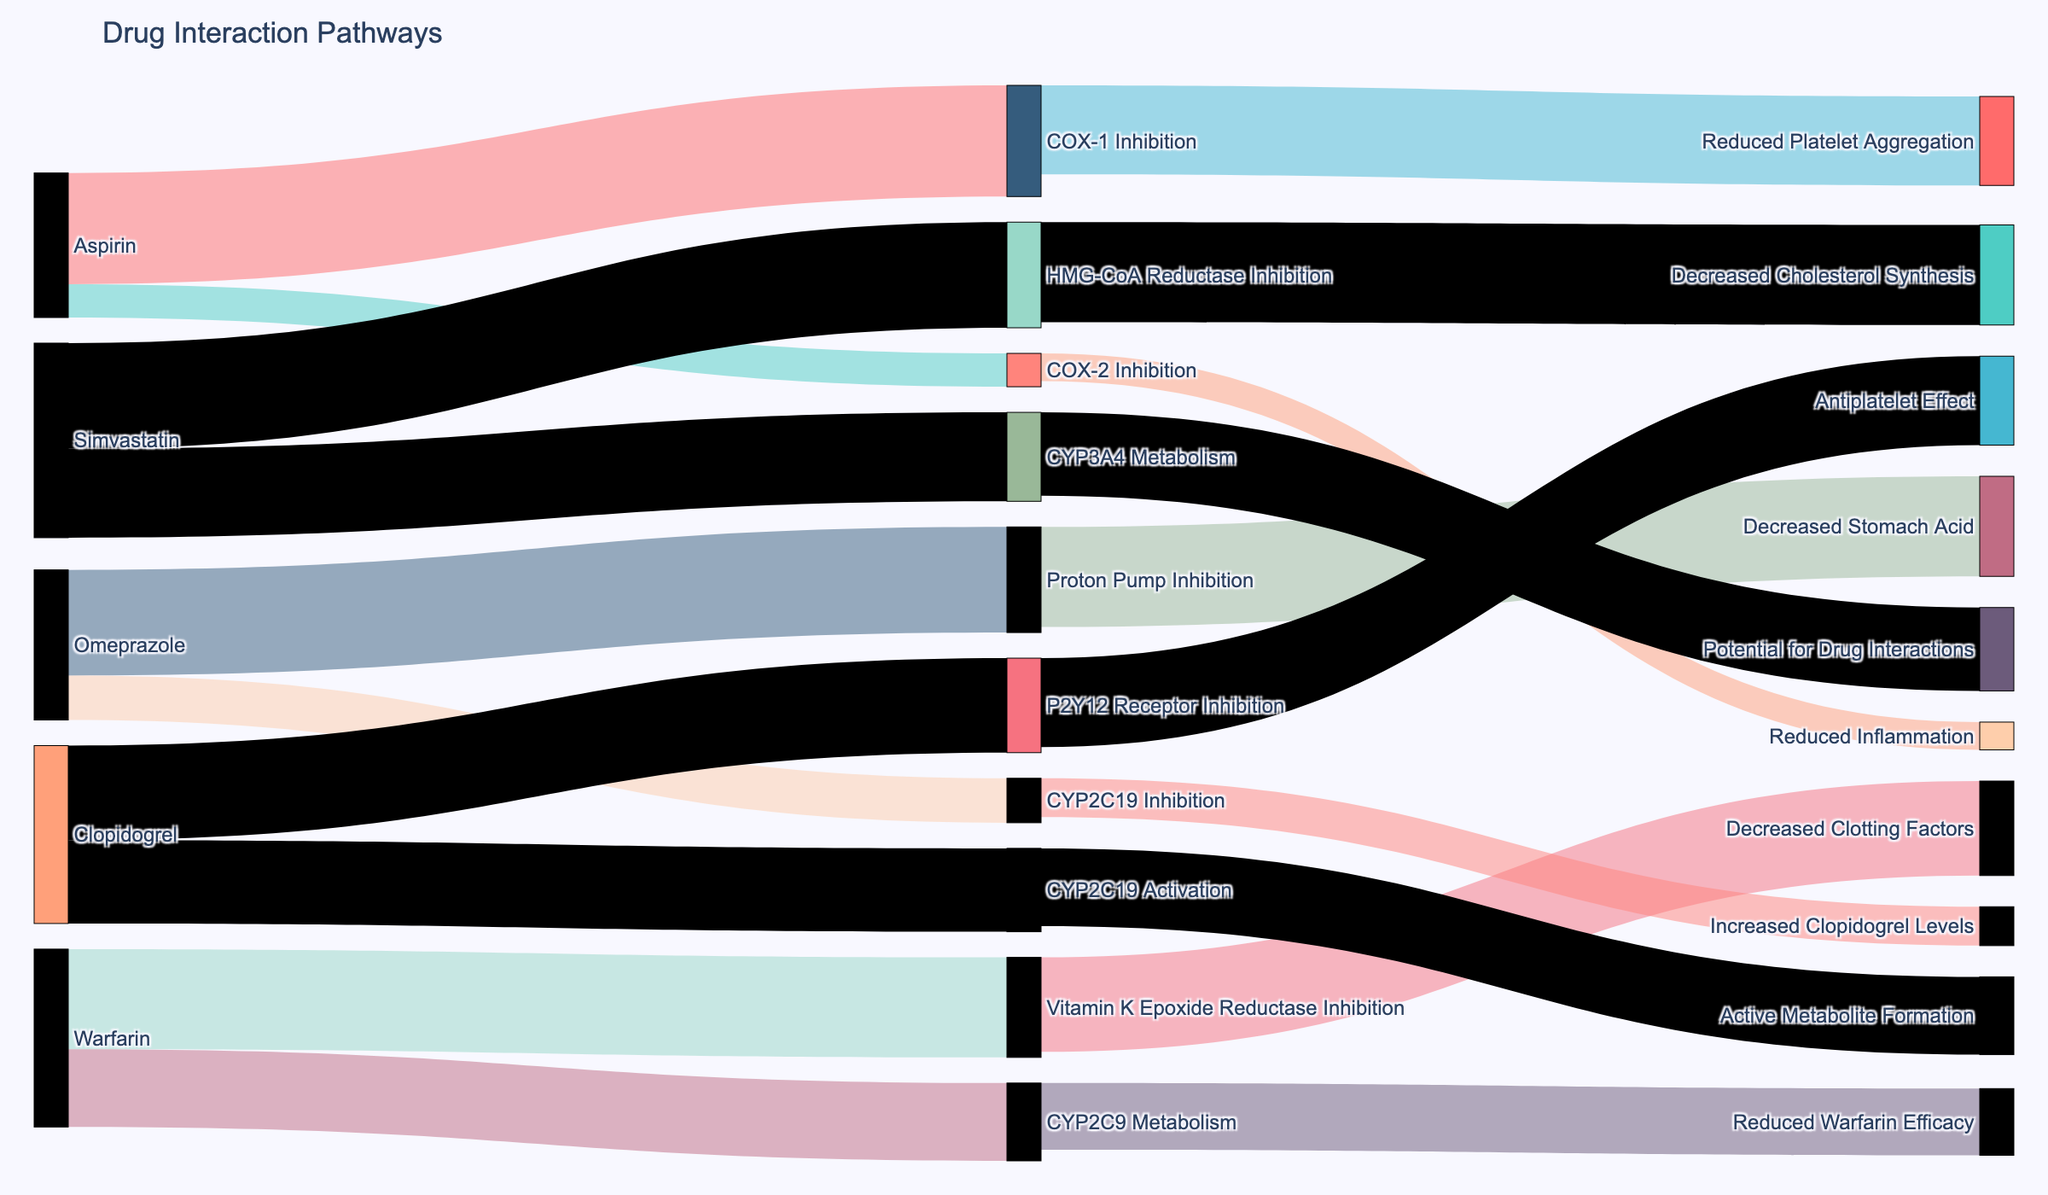What are the pathways influenced by Aspirin? The Sankey diagram shows that Aspirin affects COX-1 Inhibition and COX-2 Inhibition. COX-1 Inhibition further leads to Reduced Platelet Aggregation, and COX-2 Inhibition leads to Reduced Inflammation.
Answer: COX-1 Inhibition and COX-2 Inhibition What is the primary interaction pathway for Warfarin? By examining the Sankey diagram, we can see that Warfarin primarily interacts with Vitamin K Epoxide Reductase Inhibition and CYP2C9 Metabolism.
Answer: Vitamin K Epoxide Reductase Inhibition and CYP2C9 Metabolism Between Omeprazole and Simvastatin, which medication affects more pathways directly? The Sankey diagram shows that Omeprazole affects Proton Pump Inhibition and CYP2C19 Inhibition, resulting in two direct pathways. Simvastatin affects HMG-CoA Reductase Inhibition and CYP3A4 Metabolism, also leading to two direct pathways. Therefore, they affect an equal number of pathways directly.
Answer: Equal (2 pathways each) What are the secondary interactions arising from Clopidogrel? Clopidogrel affects P2Y12 Receptor Inhibition and CYP2C19 Activation. These lead to Antiplatelet Effect and Active Metabolite Formation, respectively, as secondary interactions.
Answer: Antiplatelet Effect and Active Metabolite Formation Which interaction pathway has the highest value? The highest value interaction in the Sankey diagram is Aspirin leading to COX-1 Inhibition with a value of 100.
Answer: Aspirin to COX-1 Inhibition What is the combined value of interactions initiated by Warfarin? Warfarin has pathways leading to Vitamin K Epoxide Reductase Inhibition with a value of 90 and CYP2C9 Metabolism with a value of 70. Combined, these values sum to 160.
Answer: 160 Which secondary interaction has a lower value, Reduced Warfarin Efficacy or Decreased Clotting Factors? Reduced Warfarin Efficacy from CYP2C9 Metabolism has a value of 60, while Decreased Clotting Factors from Vitamin K Epoxide Reductase Inhibition has a higher value of 85. Therefore, Reduced Warfarin Efficacy has a lower value.
Answer: Reduced Warfarin Efficacy How do the downstream effects of Proton Pump Inhibition compare to those of COX-2 Inhibition? From the Sankey diagram, Proton Pump Inhibition leads to Decreased Stomach Acid with a value of 90. COX-2 Inhibition leads to Reduced Inflammation with a value of 25. Proton Pump Inhibition's effect is stronger based on the values shown.
Answer: More for Proton Pump Inhibition What's the difference in value between the effects of COX-1 Inhibition and Reduced Platelet Aggregation? The value of COX-1 Inhibition is 80, and the value leading to Reduced Platelet Aggregation is also 80, so there is no difference in these values.
Answer: 0 Can you identify any multi-step interaction pathway involving Simvastatin? Yes, Simvastatin leads to HMG-CoA Reductase Inhibition, which in turn leads to Decreased Cholesterol Synthesis. Similarly, Simvastatin also leads to CYP3A4 Metabolism, resulting in Potential for Drug Interactions as secondary outcomes.
Answer: HMG-CoA Reductase Inhibition to Decreased Cholesterol Synthesis and CYP3A4 Metabolism to Potential for Drug Interactions 